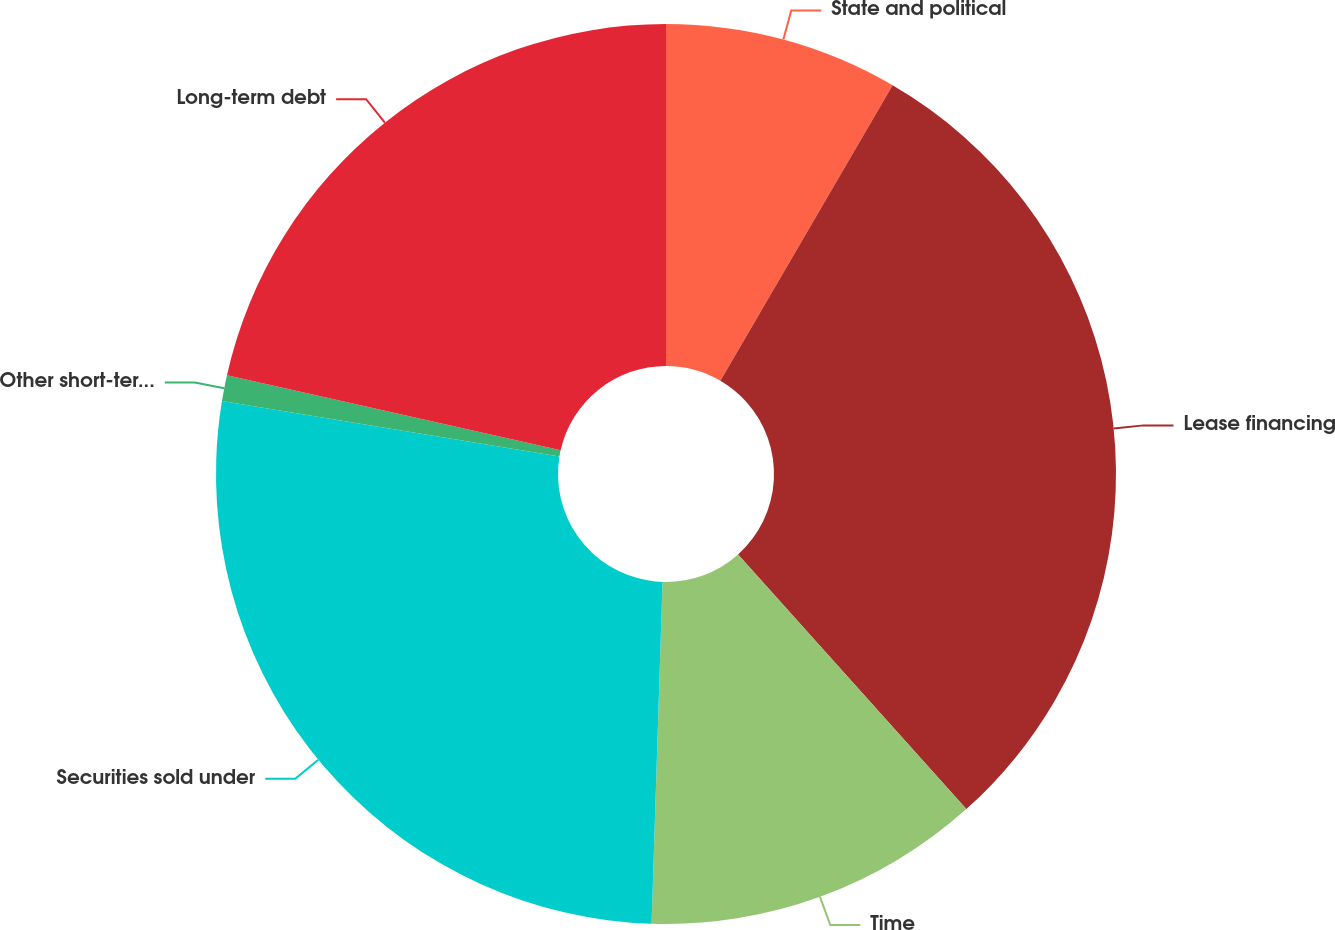Convert chart to OTSL. <chart><loc_0><loc_0><loc_500><loc_500><pie_chart><fcel>State and political<fcel>Lease financing<fcel>Time<fcel>Securities sold under<fcel>Other short-term borrowings<fcel>Long-term debt<nl><fcel>8.4%<fcel>29.97%<fcel>12.14%<fcel>27.08%<fcel>0.93%<fcel>21.48%<nl></chart> 